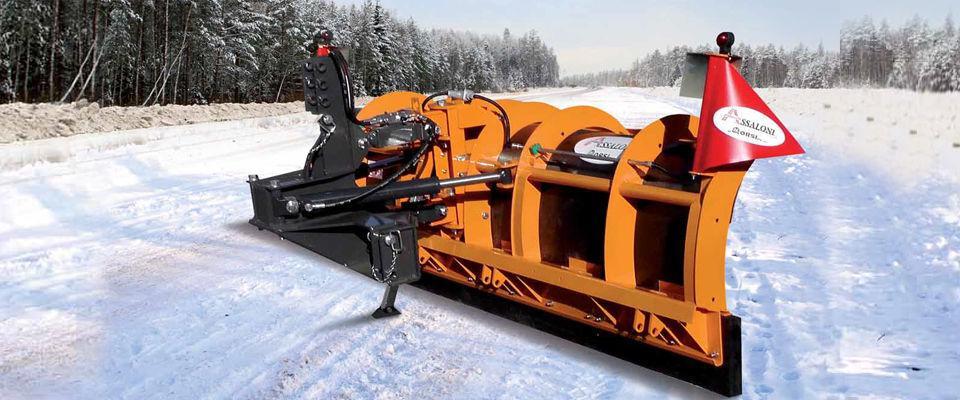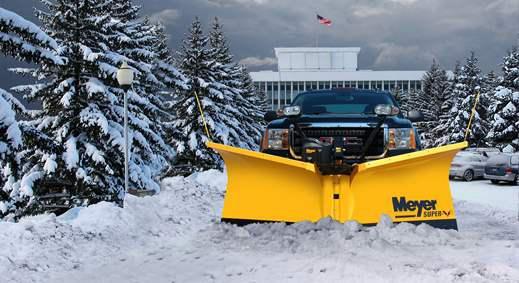The first image is the image on the left, the second image is the image on the right. Assess this claim about the two images: "There is exactly one snow plow in the right image.". Correct or not? Answer yes or no. Yes. The first image is the image on the left, the second image is the image on the right. For the images shown, is this caption "There is exactly one truck, with a yellow plow attached." true? Answer yes or no. Yes. 